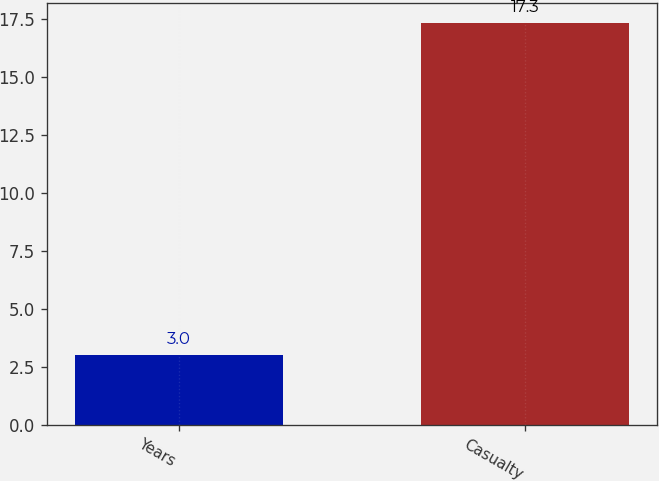<chart> <loc_0><loc_0><loc_500><loc_500><bar_chart><fcel>Years<fcel>Casualty<nl><fcel>3<fcel>17.3<nl></chart> 